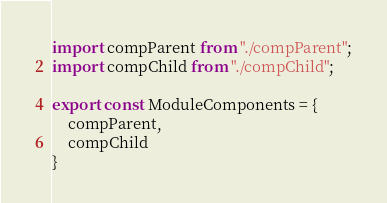<code> <loc_0><loc_0><loc_500><loc_500><_JavaScript_>import compParent from "./compParent";
import compChild from "./compChild";

export const ModuleComponents = {
    compParent,
    compChild
}
</code> 